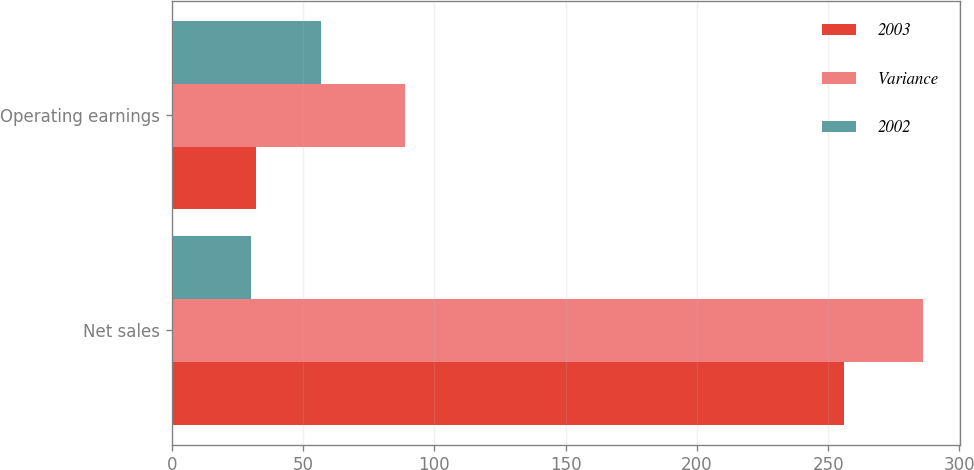Convert chart to OTSL. <chart><loc_0><loc_0><loc_500><loc_500><stacked_bar_chart><ecel><fcel>Net sales<fcel>Operating earnings<nl><fcel>2003<fcel>256<fcel>32<nl><fcel>Variance<fcel>286<fcel>89<nl><fcel>2002<fcel>30<fcel>57<nl></chart> 